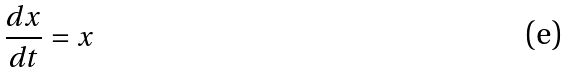Convert formula to latex. <formula><loc_0><loc_0><loc_500><loc_500>\frac { d x } { d t } = x</formula> 